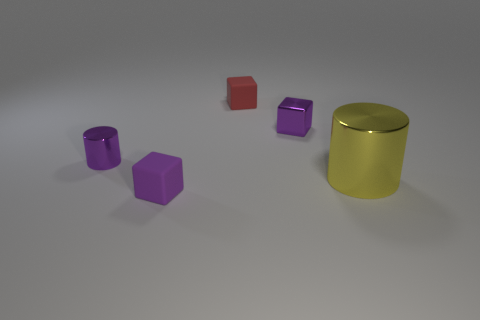Add 2 big brown things. How many objects exist? 7 Subtract all cylinders. How many objects are left? 3 Add 3 big yellow things. How many big yellow things are left? 4 Add 4 tiny blocks. How many tiny blocks exist? 7 Subtract 0 brown balls. How many objects are left? 5 Subtract all tiny objects. Subtract all yellow cylinders. How many objects are left? 0 